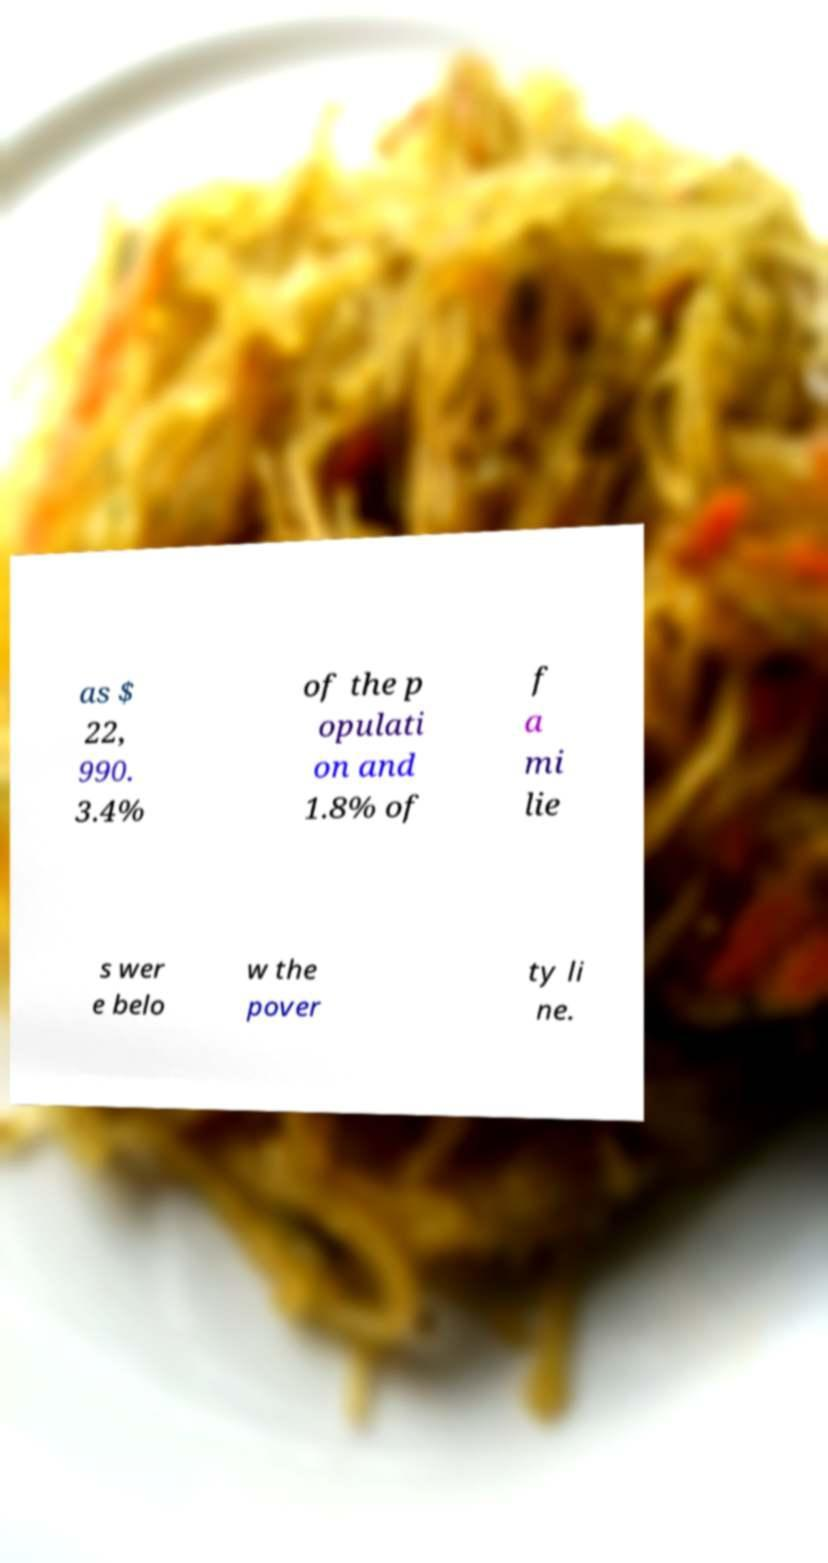Can you read and provide the text displayed in the image?This photo seems to have some interesting text. Can you extract and type it out for me? as $ 22, 990. 3.4% of the p opulati on and 1.8% of f a mi lie s wer e belo w the pover ty li ne. 